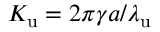Convert formula to latex. <formula><loc_0><loc_0><loc_500><loc_500>{ K _ { u } } = 2 \pi \gamma a / { \lambda _ { u } }</formula> 